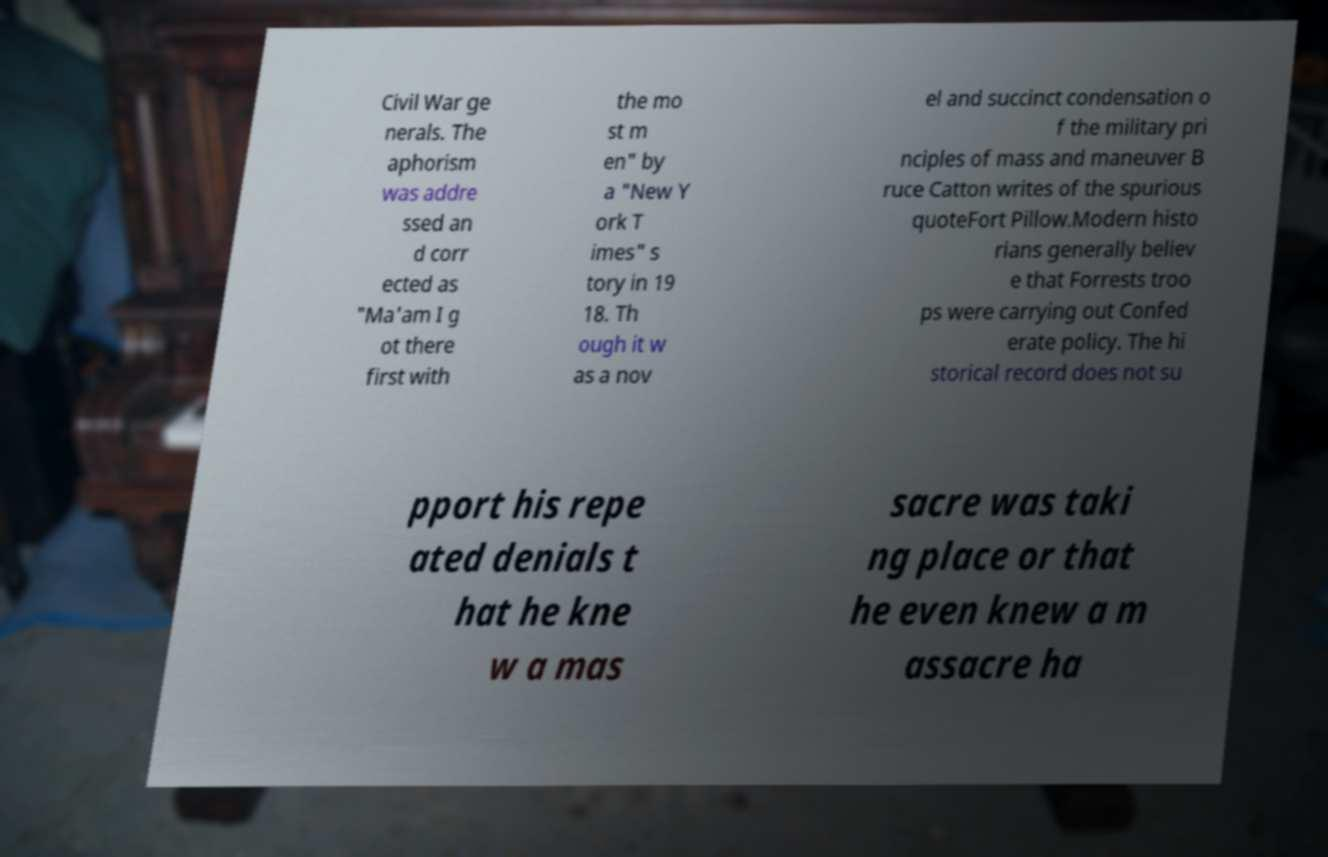Could you assist in decoding the text presented in this image and type it out clearly? Civil War ge nerals. The aphorism was addre ssed an d corr ected as "Ma'am I g ot there first with the mo st m en" by a "New Y ork T imes" s tory in 19 18. Th ough it w as a nov el and succinct condensation o f the military pri nciples of mass and maneuver B ruce Catton writes of the spurious quoteFort Pillow.Modern histo rians generally believ e that Forrests troo ps were carrying out Confed erate policy. The hi storical record does not su pport his repe ated denials t hat he kne w a mas sacre was taki ng place or that he even knew a m assacre ha 